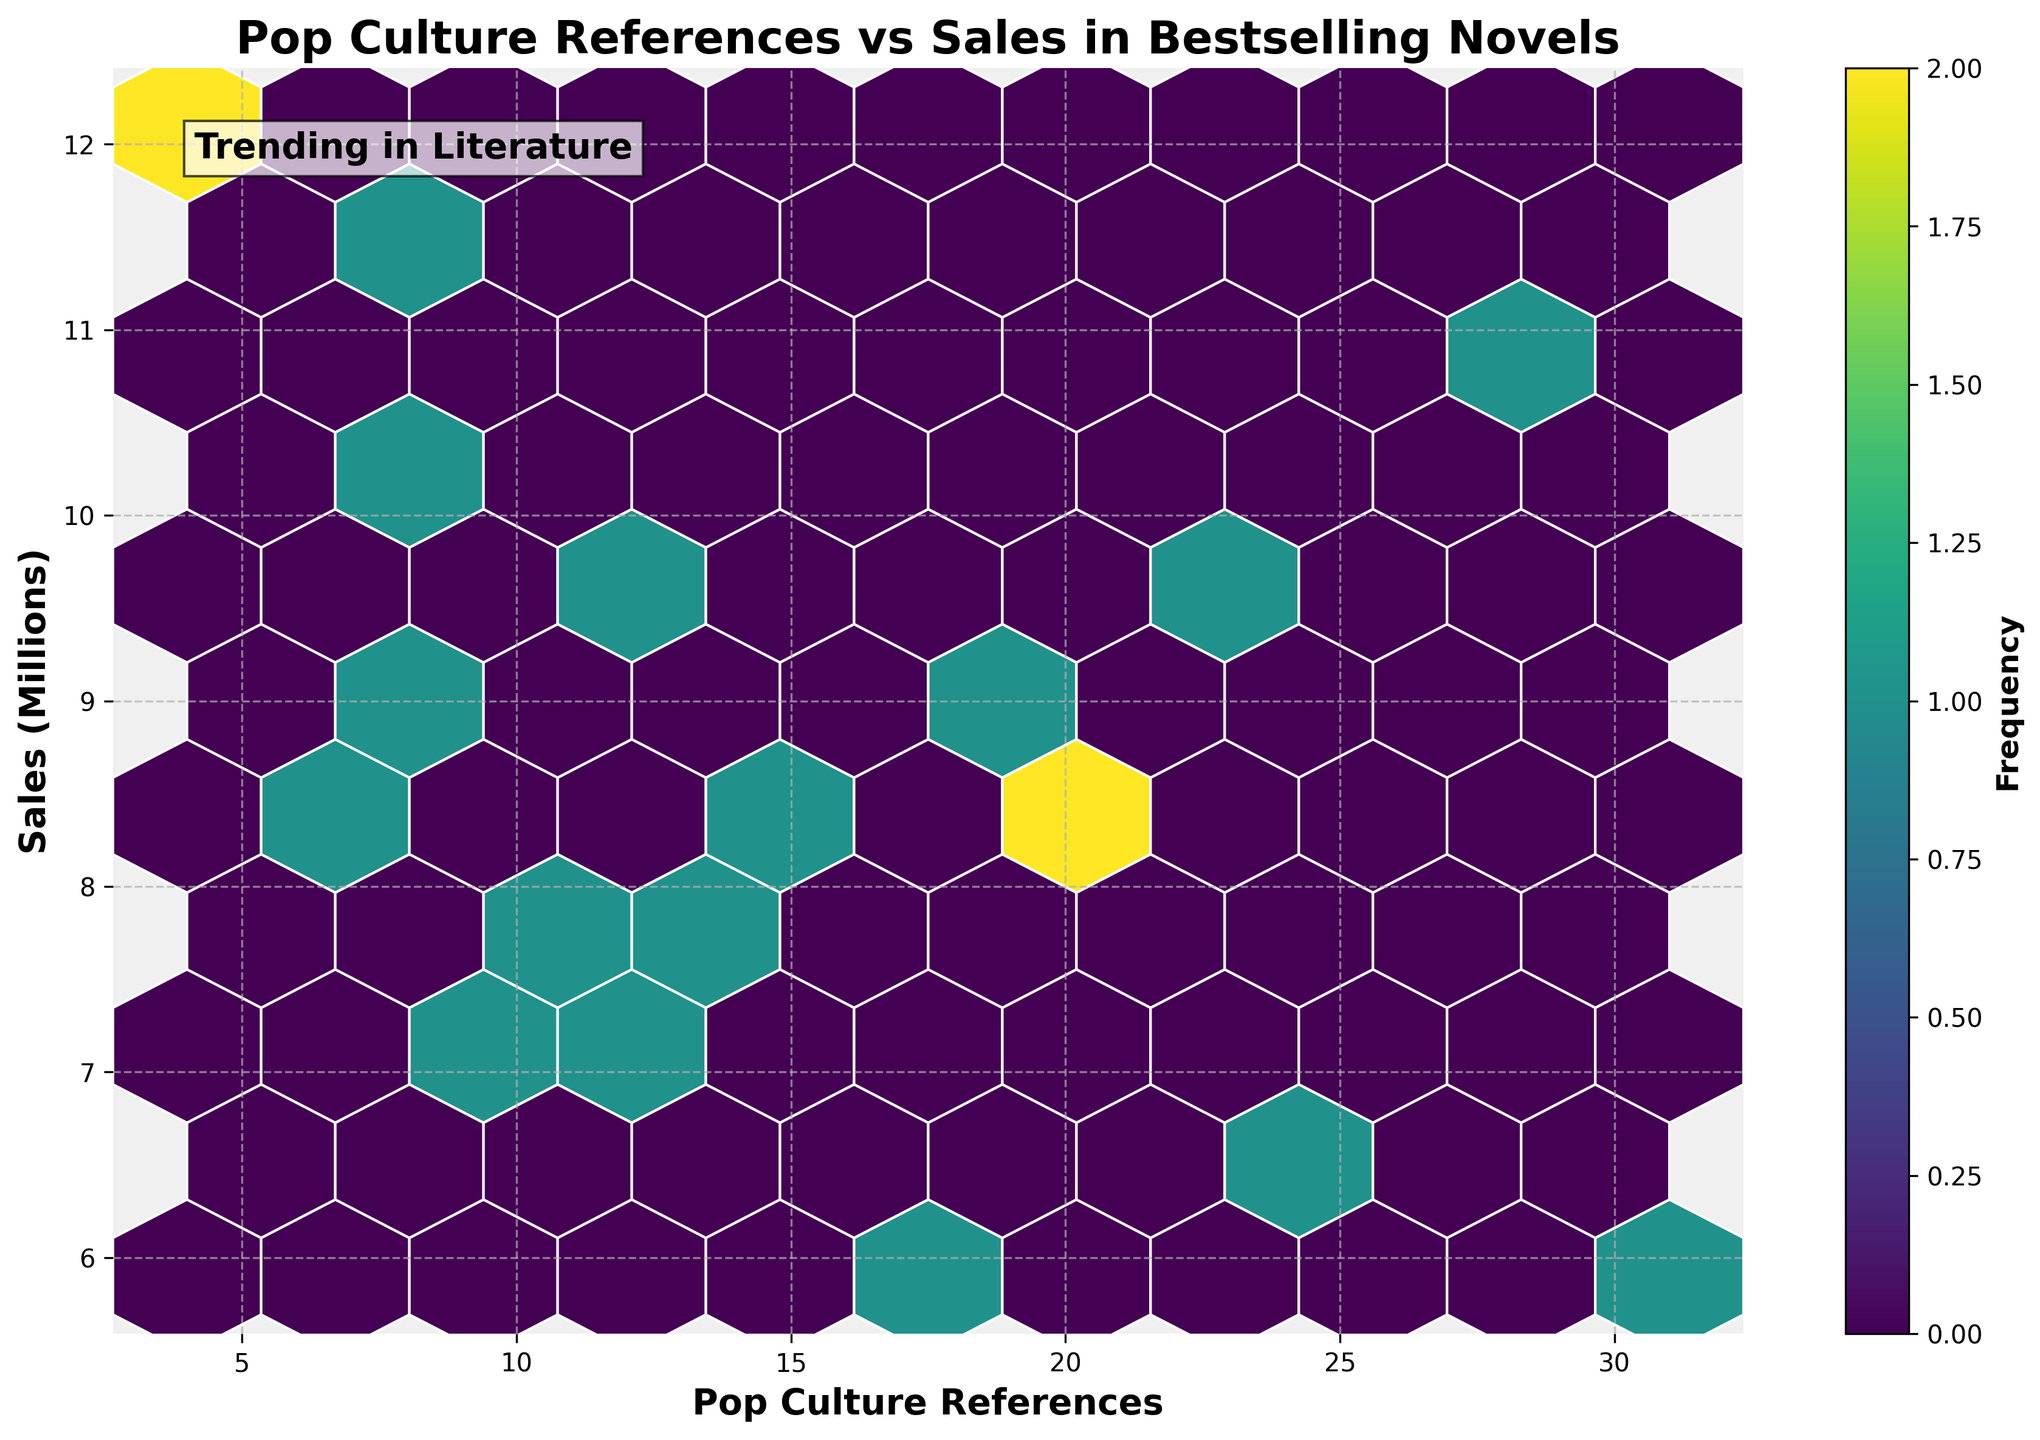What is the title of the figure? The title of the figure is located at the top of the plot and provides a summary of what the plot represents. The title in this case is "Pop Culture References vs Sales in Bestselling Novels".
Answer: Pop Culture References vs Sales in Bestselling Novels What are the labels for the x-axis and y-axis? The x-axis and y-axis labels are located below the horizontal axis and to the left of the vertical axis, respectively. They describe what each axis represents. The x-axis is labeled "Pop Culture References" and the y-axis is labeled "Sales (Millions)".
Answer: Pop Culture References; Sales (Millions) How many bins are displayed in the hexbin plot? Each hexagon on the plot represents a bin, and they are arranged in a grid pattern. The number of bins can be counted by looking at the hexagons in the grid.
Answer: 10 Which bin has the highest frequency? The bin with the highest frequency will be the one with the darkest color shade, as the color intensity is indicative of frequency.
Answer: The bin in the range of approximately 8-12 pop culture references and 8-10 million in sales What is the color of hexagons used in the plot? The hexagons use a colormap to indicate frequency; the specific colormap used is 'viridis', which typically varies from yellow to purple. The color intensity corresponds to the number of data points in each bin.
Answer: Yellow to purple What range of sales (in millions) is most densely populated with data points? To determine the most densely populated sales range, look for the vertical section of the hexbin plot with the highest concentration of darker hexagons.
Answer: 8-10 million in sales How do the number of pop culture references and the sales relate to each other? By observing the overall distribution of the hexagons, one can infer if there is a trend. If hexagons are clustered in a specific direction, it indicates a correlation. In general, darker regions might suggest a positive or negative trend based on their positioning.
Answer: No clear linear trend; concentration around 8-12 references and 8-10 million sales What does the color bar represent in the hexbin plot? The color bar, located usually to the side of the plot, indicates what the different colors in the hexagons represent. It is used to show the frequency of data points within each bin in this plot.
Answer: Frequency Identify a year with a bestselling novel having fewer than 10 pop culture references but sales above 10 million. By referencing the given data against the parameters of fewer than 10 pop culture references and sales above 10 million, and looking at the plot, you can see which years match this condition.
Answer: 2015 (The Girl on the Train) Does the plot indicate any novels that have both a high number of pop culture references and high sales? High number of pop culture references refers to values towards the right of the plot, while high sales are towards the top. If there is a darker hexagon in the upper right section, it would indicate such novels.
Answer: No, higher pop culture references do not coincide with high sales 